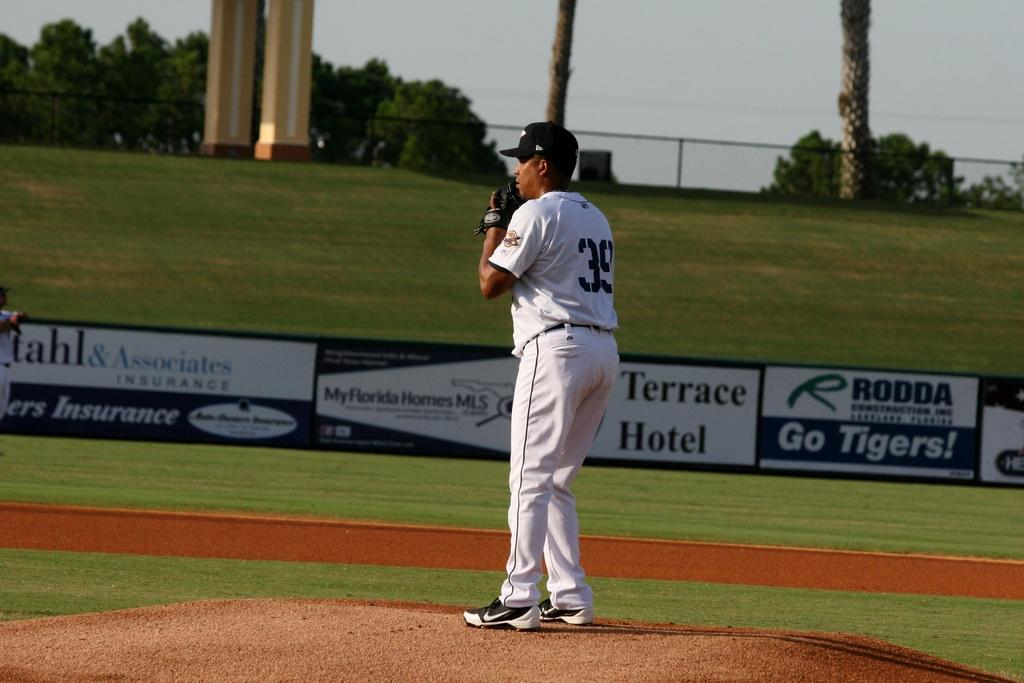Provide a one-sentence caption for the provided image. a pitcher with a large terrace hotel sign in the back. 